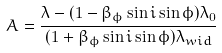Convert formula to latex. <formula><loc_0><loc_0><loc_500><loc_500>A = \frac { \lambda - ( 1 - \beta _ { \phi } \sin i \sin \phi ) \lambda _ { 0 } } { ( 1 + \beta _ { \phi } \sin i \sin \phi ) \lambda _ { w i d } }</formula> 